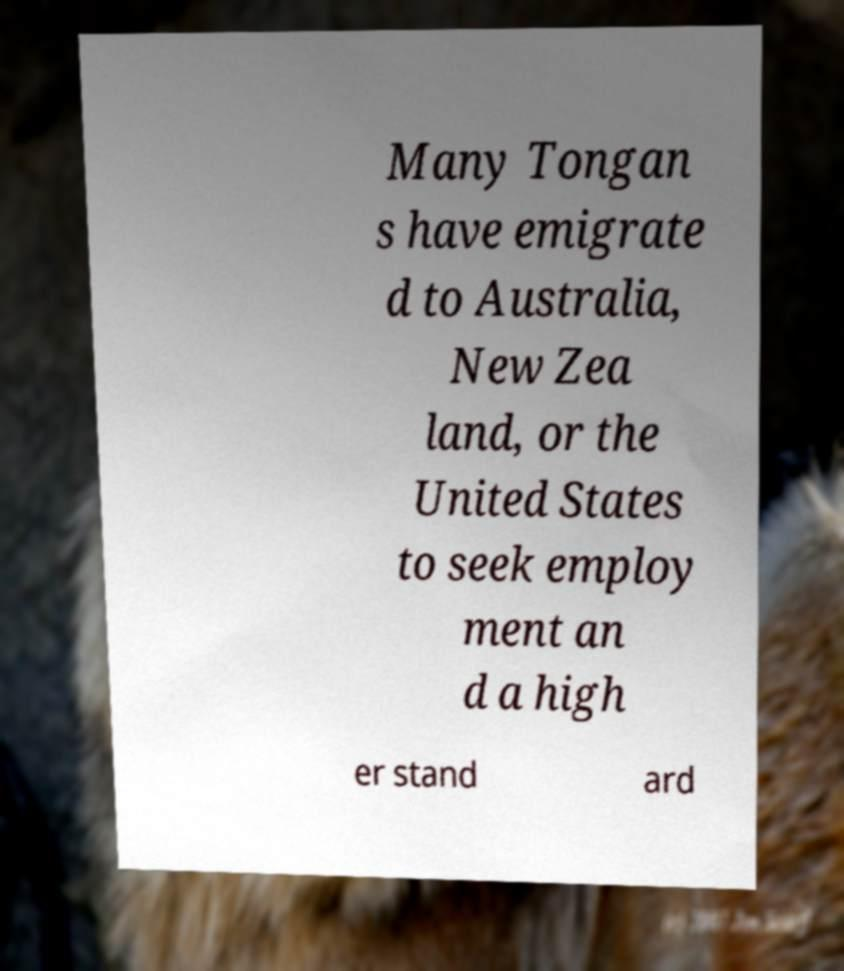Can you accurately transcribe the text from the provided image for me? Many Tongan s have emigrate d to Australia, New Zea land, or the United States to seek employ ment an d a high er stand ard 